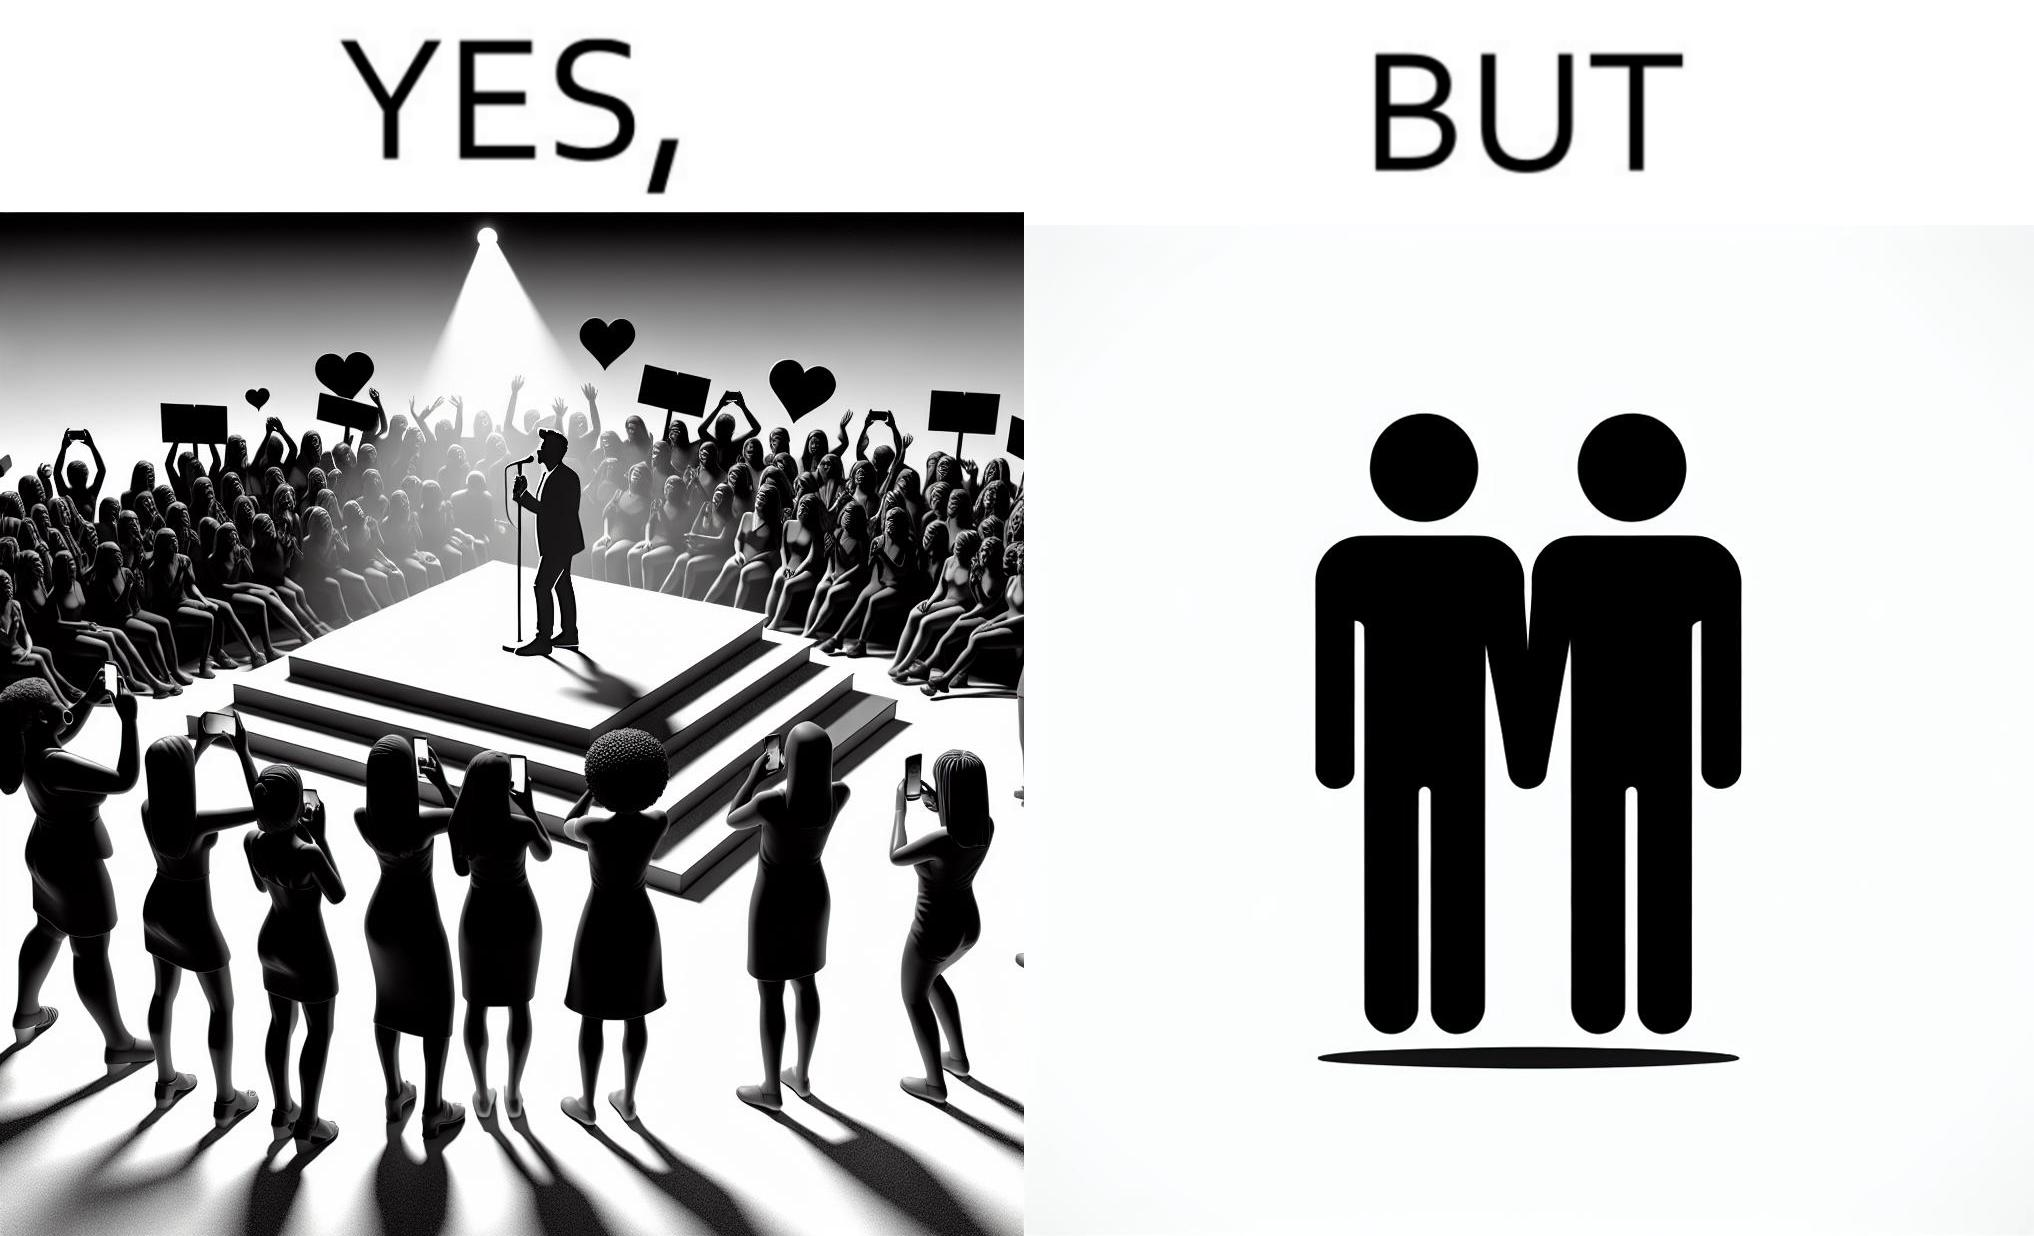What is shown in this image? The image is funny because while the girls loves the man, he likes other men instead of women. 